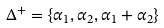<formula> <loc_0><loc_0><loc_500><loc_500>\Delta ^ { + } = \left \{ \alpha _ { 1 } , \alpha _ { 2 } , \alpha _ { 1 } + \alpha _ { 2 } \right \}</formula> 